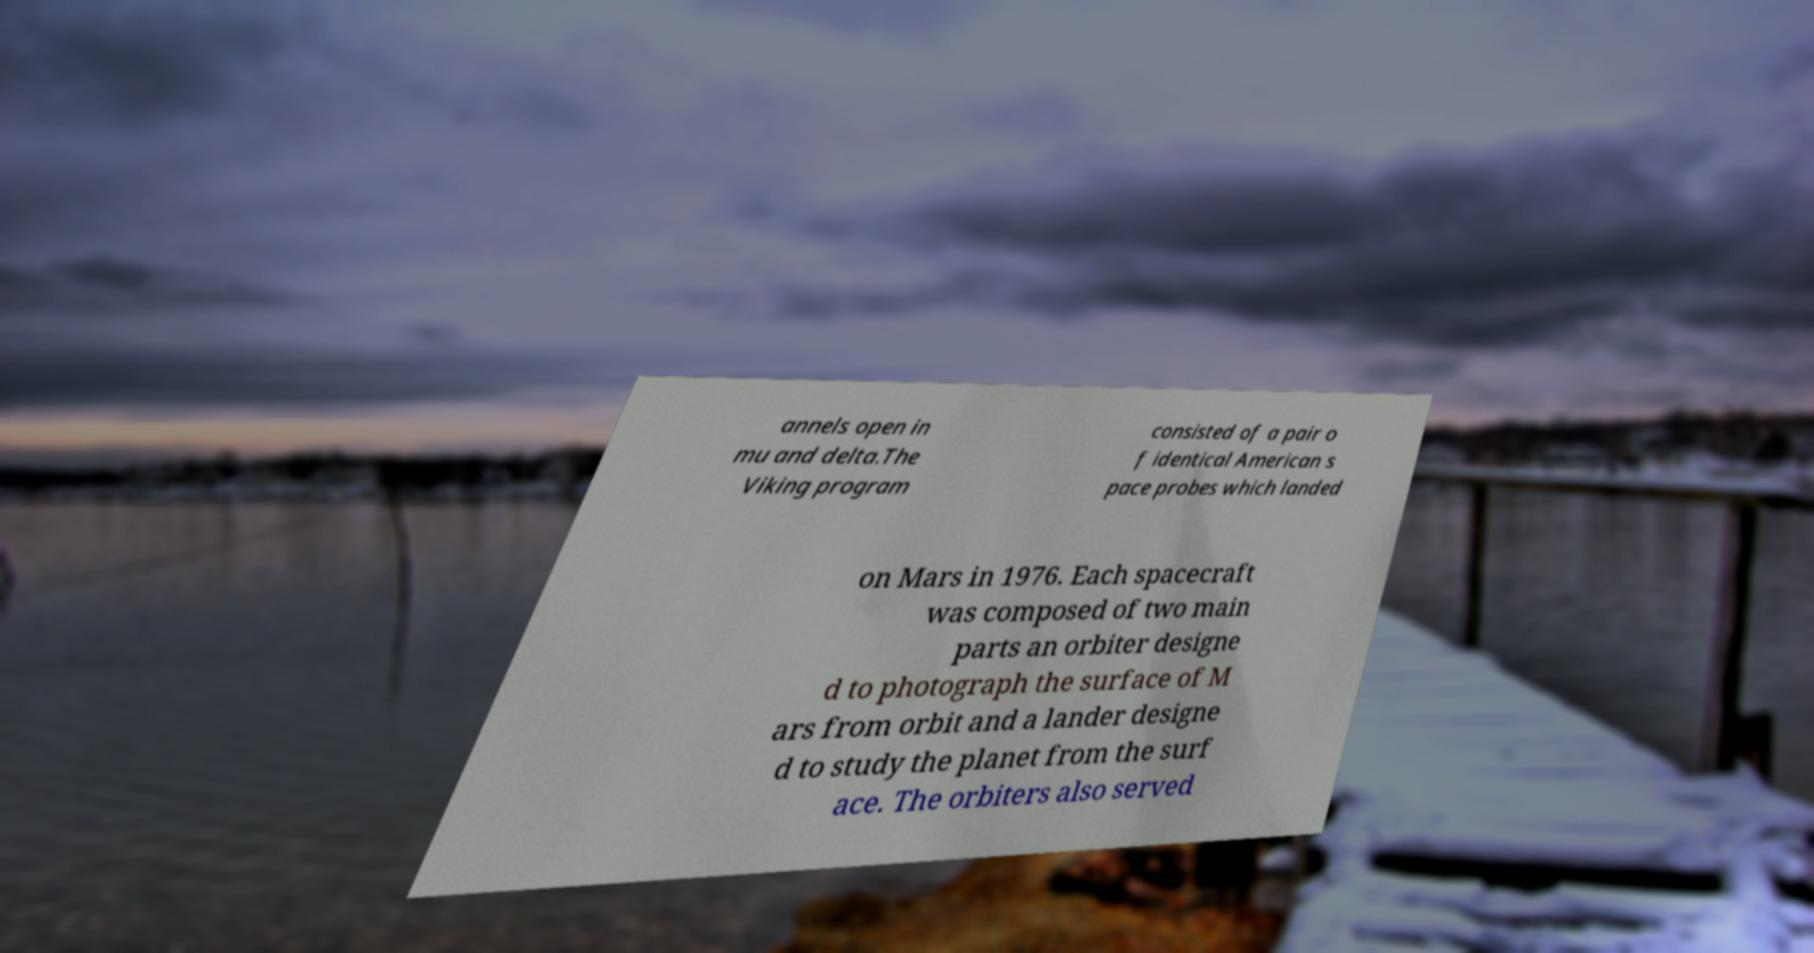For documentation purposes, I need the text within this image transcribed. Could you provide that? annels open in mu and delta.The Viking program consisted of a pair o f identical American s pace probes which landed on Mars in 1976. Each spacecraft was composed of two main parts an orbiter designe d to photograph the surface of M ars from orbit and a lander designe d to study the planet from the surf ace. The orbiters also served 